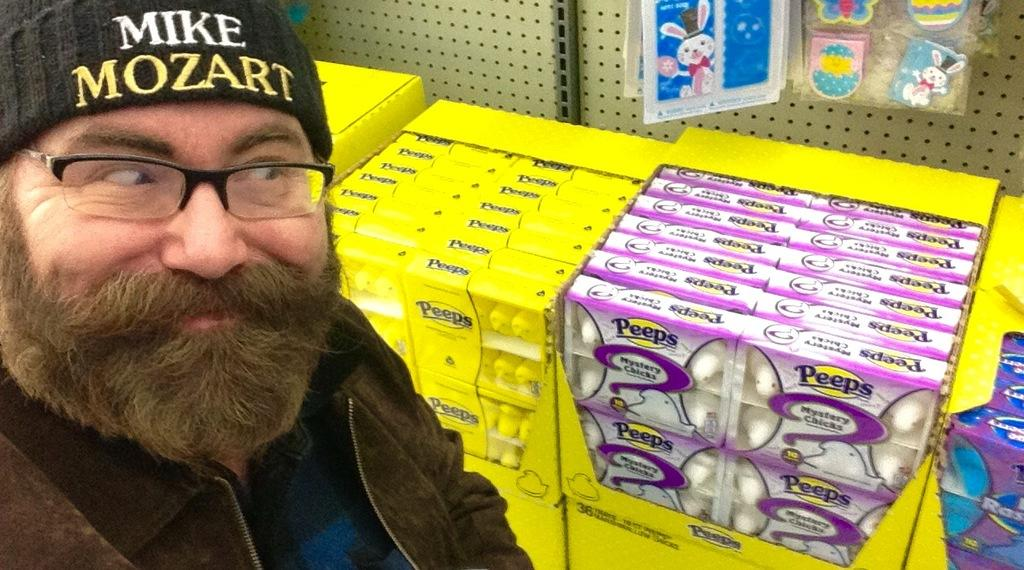Who is present in the image? There is a person in the image. Where is the person located in the image? The person is on the left side of the image. What accessories is the person wearing? The person is wearing a cap and spectacles. What objects can be seen in the image besides the person? There are boxes and items hanging at the back in the image. What is the person's opinion on apples in the image? There is no information about the person's opinion on apples in the image. Is the person's dad present in the image? There is no mention of the person's dad in the image. 